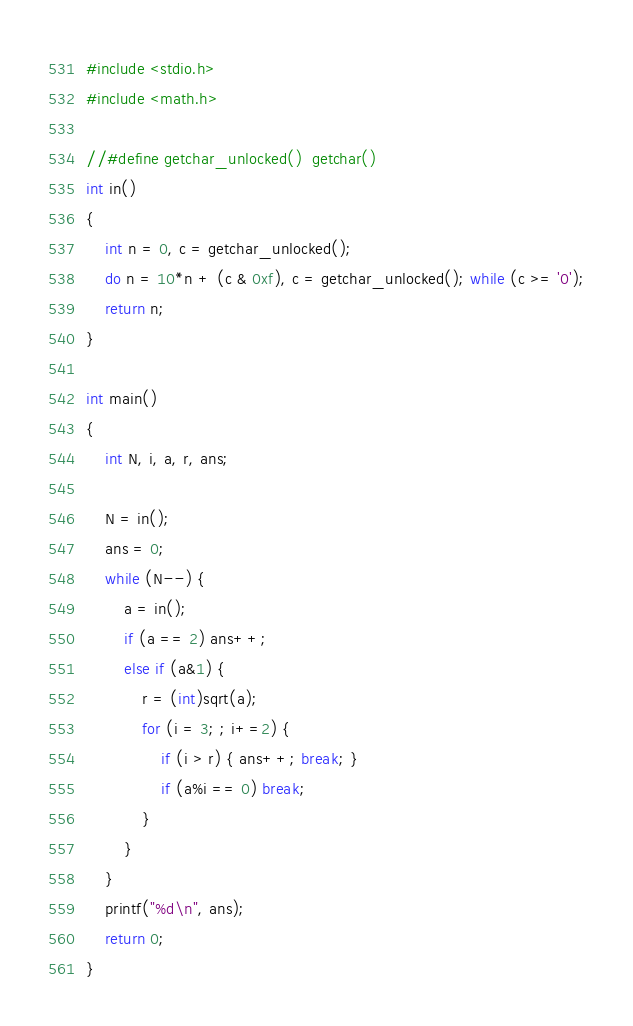<code> <loc_0><loc_0><loc_500><loc_500><_C_>#include <stdio.h>
#include <math.h>
 
//#define getchar_unlocked()  getchar()
int in()
{
    int n = 0, c = getchar_unlocked();
    do n = 10*n + (c & 0xf), c = getchar_unlocked(); while (c >= '0');
    return n;
}
 
int main()
{
    int N, i, a, r, ans;
 
    N = in();
    ans = 0;
    while (N--) {
        a = in();
        if (a == 2) ans++;
        else if (a&1) {
            r = (int)sqrt(a);
            for (i = 3; ; i+=2) {
                if (i > r) { ans++; break; }
                if (a%i == 0) break;
            }
        }
    }
    printf("%d\n", ans);
    return 0;
}
</code> 